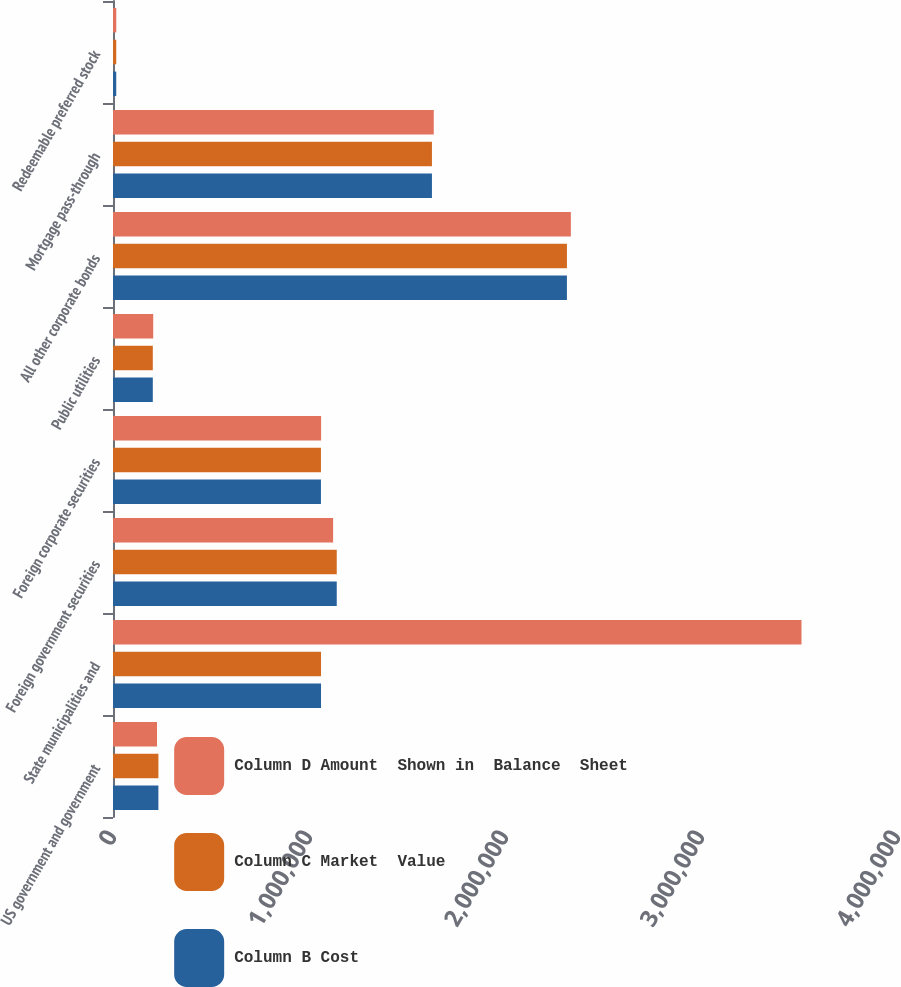<chart> <loc_0><loc_0><loc_500><loc_500><stacked_bar_chart><ecel><fcel>US government and government<fcel>State municipalities and<fcel>Foreign government securities<fcel>Foreign corporate securities<fcel>Public utilities<fcel>All other corporate bonds<fcel>Mortgage pass-through<fcel>Redeemable preferred stock<nl><fcel>Column D Amount  Shown in  Balance  Sheet<fcel>224563<fcel>3.51269e+06<fcel>1.12299e+06<fcel>1.06176e+06<fcel>205186<fcel>2.33596e+06<fcel>1.63654e+06<fcel>16654<nl><fcel>Column C Market  Value<fcel>231621<fcel>1.06137e+06<fcel>1.14162e+06<fcel>1.06097e+06<fcel>203095<fcel>2.31594e+06<fcel>1.62724e+06<fcel>16573<nl><fcel>Column B Cost<fcel>231621<fcel>1.06137e+06<fcel>1.14162e+06<fcel>1.06097e+06<fcel>203095<fcel>2.31594e+06<fcel>1.62724e+06<fcel>16573<nl></chart> 